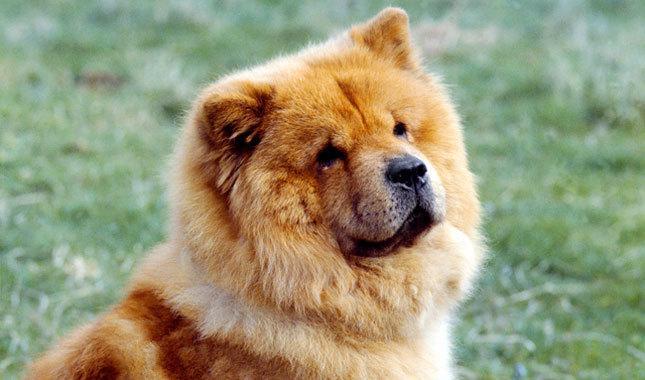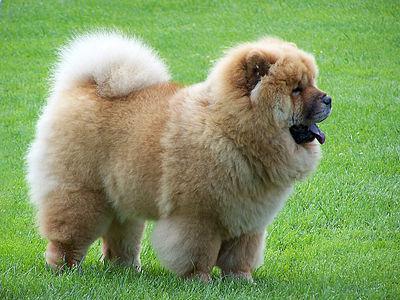The first image is the image on the left, the second image is the image on the right. Assess this claim about the two images: "An image shows a chow standing on a brick-type surface.". Correct or not? Answer yes or no. No. The first image is the image on the left, the second image is the image on the right. For the images shown, is this caption "One of the images only shows the head of a dog." true? Answer yes or no. Yes. 